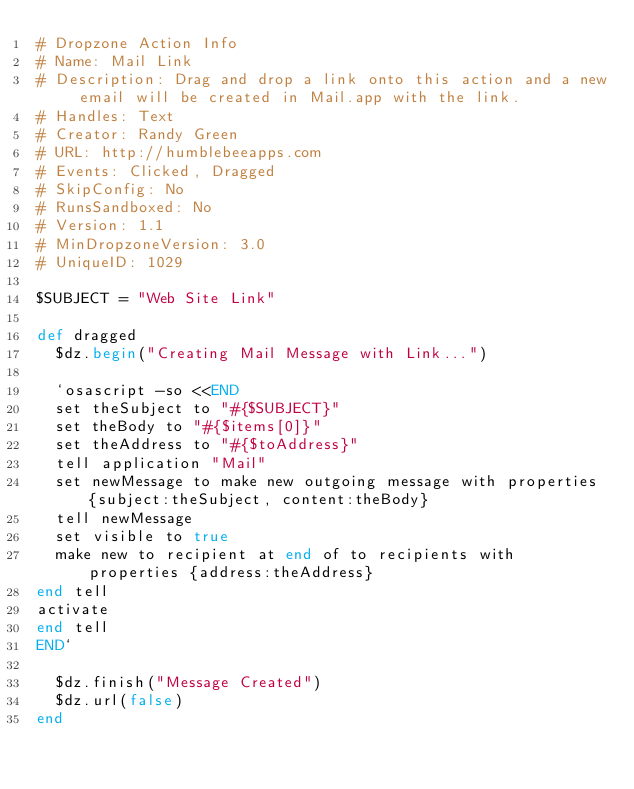<code> <loc_0><loc_0><loc_500><loc_500><_Ruby_># Dropzone Action Info
# Name: Mail Link
# Description: Drag and drop a link onto this action and a new email will be created in Mail.app with the link.
# Handles: Text
# Creator: Randy Green
# URL: http://humblebeeapps.com
# Events: Clicked, Dragged
# SkipConfig: No
# RunsSandboxed: No
# Version: 1.1
# MinDropzoneVersion: 3.0
# UniqueID: 1029

$SUBJECT = "Web Site Link"

def dragged
  $dz.begin("Creating Mail Message with Link...")
        
  `osascript -so <<END
  set theSubject to "#{$SUBJECT}"
  set theBody to "#{$items[0]}"
  set theAddress to "#{$toAddress}"
  tell application "Mail"
  set newMessage to make new outgoing message with properties {subject:theSubject, content:theBody}
  tell newMessage
  set visible to true
  make new to recipient at end of to recipients with properties {address:theAddress}
end tell
activate
end tell
END`

  $dz.finish("Message Created")
  $dz.url(false)
end
</code> 